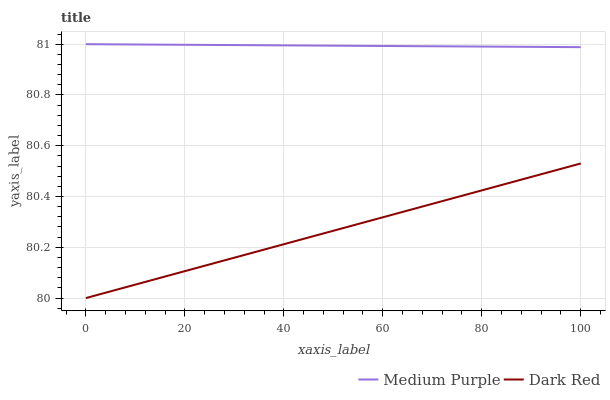Does Dark Red have the minimum area under the curve?
Answer yes or no. Yes. Does Medium Purple have the maximum area under the curve?
Answer yes or no. Yes. Does Dark Red have the maximum area under the curve?
Answer yes or no. No. Is Dark Red the smoothest?
Answer yes or no. Yes. Is Medium Purple the roughest?
Answer yes or no. Yes. Is Dark Red the roughest?
Answer yes or no. No. Does Medium Purple have the highest value?
Answer yes or no. Yes. Does Dark Red have the highest value?
Answer yes or no. No. Is Dark Red less than Medium Purple?
Answer yes or no. Yes. Is Medium Purple greater than Dark Red?
Answer yes or no. Yes. Does Dark Red intersect Medium Purple?
Answer yes or no. No. 